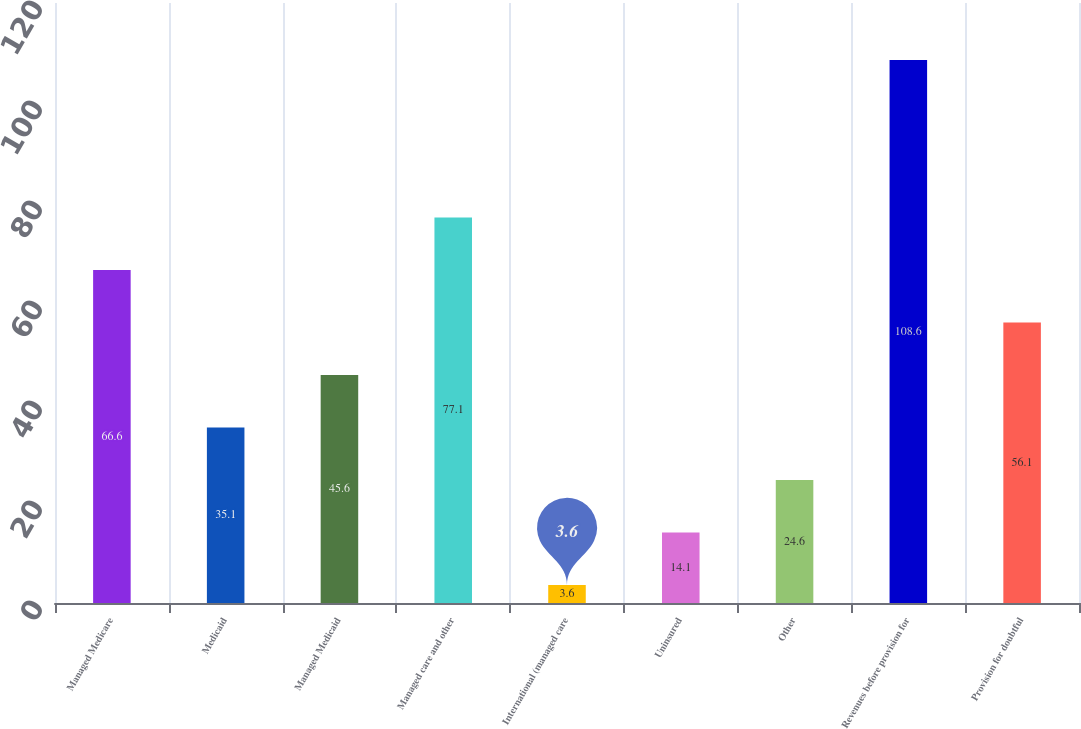<chart> <loc_0><loc_0><loc_500><loc_500><bar_chart><fcel>Managed Medicare<fcel>Medicaid<fcel>Managed Medicaid<fcel>Managed care and other<fcel>International (managed care<fcel>Uninsured<fcel>Other<fcel>Revenues before provision for<fcel>Provision for doubtful<nl><fcel>66.6<fcel>35.1<fcel>45.6<fcel>77.1<fcel>3.6<fcel>14.1<fcel>24.6<fcel>108.6<fcel>56.1<nl></chart> 